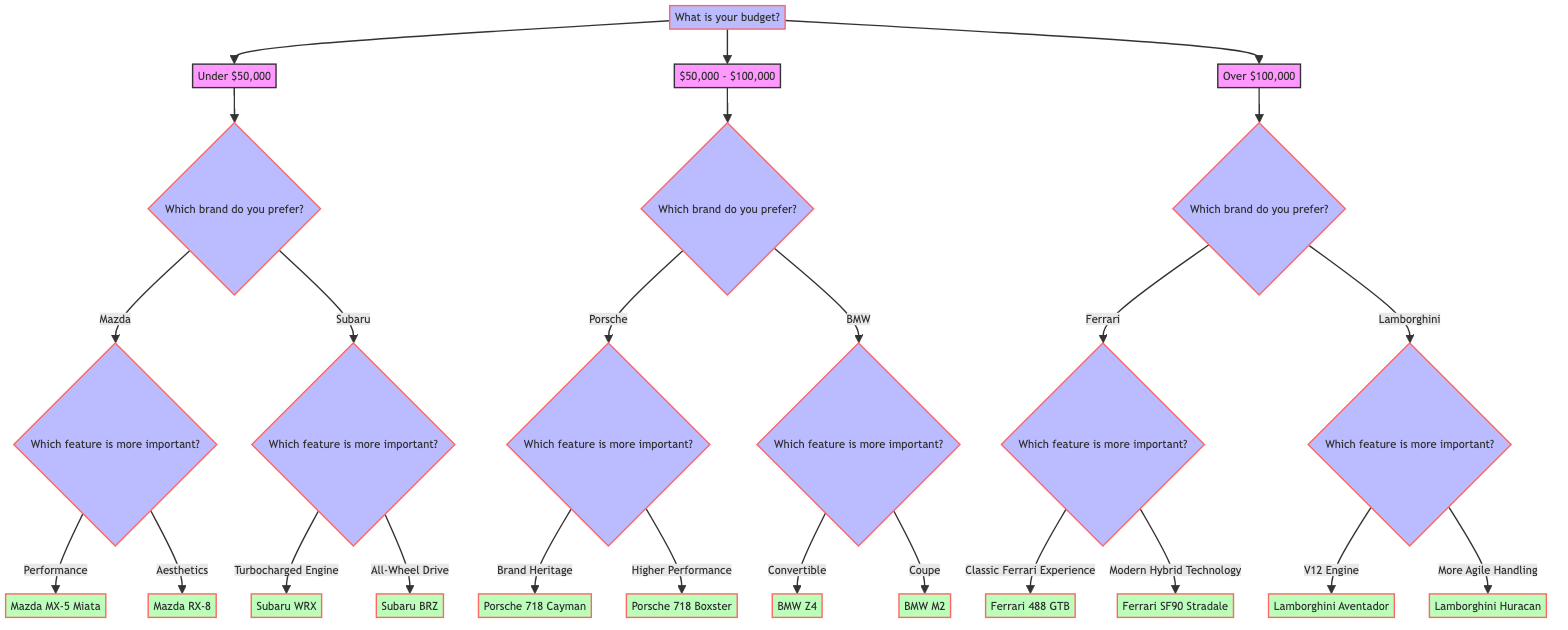What is the first question in the diagram? The diagram begins at the root node, which is the first question posed. It asks about the budget of the person deciding on a sports car.
Answer: What is your budget? How many brands are available for a budget under $50,000? Under the option for a budget under $50,000, two brands are given as choices: Mazda and Subaru. This can be counted directly from the options linked to this budget node.
Answer: 2 If I choose Porsche under a budget of $50,000 - $100,000, what will be my next question? After selecting Porsche, the next question to determine the most preferred feature will be presented. This question specifically asks for the feature that is more important.
Answer: Which feature is more important to you? What sports car will I get if I prefer aesthetics under Mazda? If you choose Mazda and select aesthetics as your preferred feature, the diagram indicates that you will get the Mazda RX-8 as the output. This output is directly linked to the aesthetics choice under Mazda.
Answer: Mazda RX-8 Which sports car is suggested if I like turbocharged engines and have a budget under $50,000? If the budget is under $50,000 and turbocharged engines are preferred, the only option that aligns with both choices is the Subaru WRX, according to the branches of the decision tree.
Answer: Subaru WRX What feature should I prioritize to get Lamborghini Huracan? To achieve the output of Lamborghini Huracan, the diagram indicates that you should prioritize more agile handling as your preferred feature under the Lamborghini brand, which is presented after selecting Lamborghini as your preferred brand with a budget over $100,000.
Answer: More Agile Handling How many total distinct sports car models are offered in the decision tree? By counting the leaf nodes at the end of each branch in the decision tree, we can see that there are a total of 8 distinct sports car models suggested within the entire diagram.
Answer: 8 If I increase my budget to over $100,000, what brands can I choose from? With a budget set over $100,000, the decision tree shows two options available for selection: Ferrari and Lamborghini. This is determined by following the path in the tree specifically for that budget range.
Answer: Ferrari, Lamborghini 